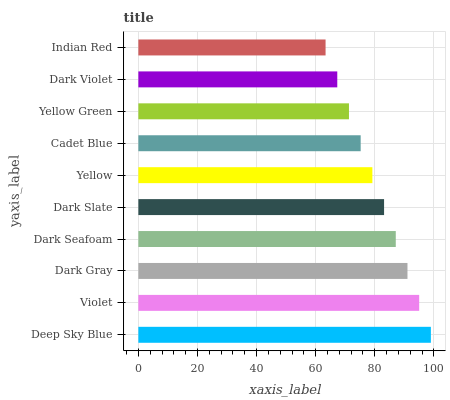Is Indian Red the minimum?
Answer yes or no. Yes. Is Deep Sky Blue the maximum?
Answer yes or no. Yes. Is Violet the minimum?
Answer yes or no. No. Is Violet the maximum?
Answer yes or no. No. Is Deep Sky Blue greater than Violet?
Answer yes or no. Yes. Is Violet less than Deep Sky Blue?
Answer yes or no. Yes. Is Violet greater than Deep Sky Blue?
Answer yes or no. No. Is Deep Sky Blue less than Violet?
Answer yes or no. No. Is Dark Slate the high median?
Answer yes or no. Yes. Is Yellow the low median?
Answer yes or no. Yes. Is Dark Seafoam the high median?
Answer yes or no. No. Is Violet the low median?
Answer yes or no. No. 